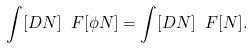Convert formula to latex. <formula><loc_0><loc_0><loc_500><loc_500>\int [ D N ] \ F [ \phi N ] = \int [ D N ] \ F [ N ] .</formula> 